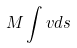<formula> <loc_0><loc_0><loc_500><loc_500>M \int v d s</formula> 